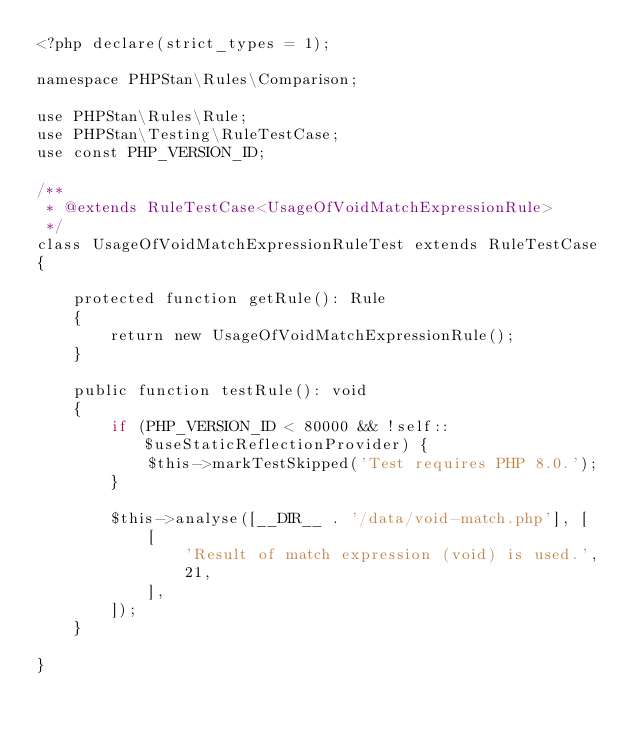<code> <loc_0><loc_0><loc_500><loc_500><_PHP_><?php declare(strict_types = 1);

namespace PHPStan\Rules\Comparison;

use PHPStan\Rules\Rule;
use PHPStan\Testing\RuleTestCase;
use const PHP_VERSION_ID;

/**
 * @extends RuleTestCase<UsageOfVoidMatchExpressionRule>
 */
class UsageOfVoidMatchExpressionRuleTest extends RuleTestCase
{

	protected function getRule(): Rule
	{
		return new UsageOfVoidMatchExpressionRule();
	}

	public function testRule(): void
	{
		if (PHP_VERSION_ID < 80000 && !self::$useStaticReflectionProvider) {
			$this->markTestSkipped('Test requires PHP 8.0.');
		}

		$this->analyse([__DIR__ . '/data/void-match.php'], [
			[
				'Result of match expression (void) is used.',
				21,
			],
		]);
	}

}
</code> 